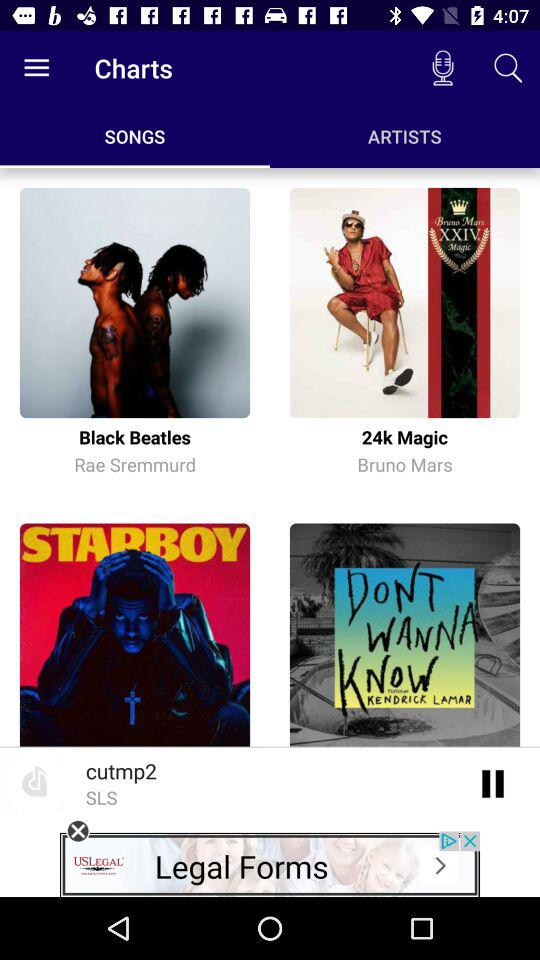Who is the composer of the song "Black Beatles"? The composer of the song is Rae Sremmurd. 